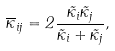<formula> <loc_0><loc_0><loc_500><loc_500>\overline { \kappa } _ { i j } = 2 \frac { \tilde { \kappa } _ { i } \tilde { \kappa } _ { j } } { \tilde { \kappa } _ { i } + \tilde { \kappa } _ { j } } ,</formula> 